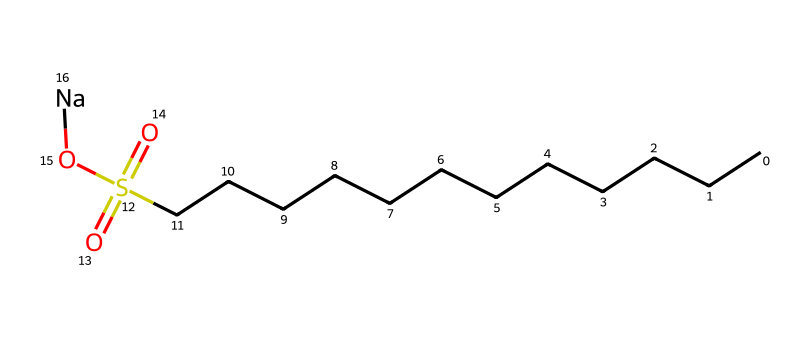What type of chemical is represented by this SMILES? The SMILES represents an alkylbenzene sulfonate, which is known for its use in detergents. The presence of the sulfonate group (S(=O)(=O)O) indicates it's a sulfonic acid derivative, often used for its surfactant properties.
Answer: alkylbenzene sulfonate How many carbon atoms are in this molecule? By analyzing the chain of "C" symbols in the SMILES representation, we count a total of 12 carbon atoms represented here (CCCCCCCCCCCC).
Answer: 12 What does the "Na" represent at the end of the SMILES? The "Na" at the end indicates that this compound is sodium salt of alkylbenzene sulfonate, which enhances its solubility in water, making it effective in cleaning applications.
Answer: sodium How many sulfur atoms are in the molecule? The letter "S" in the SMILES indicates there is one sulfur atom present in the structure, which is part of the sulfonate group.
Answer: 1 What functional group is indicated by "S(=O)(=O)O"? The "S(=O)(=O)O" part of the SMILES shows a sulfonate functional group, which is characterized by a sulfur atom bonded to two oxygen atoms with double bonds and one hydroxyl group. This specific structure is key to its surfactant properties.
Answer: sulfonate Why is this chemical effective in cleaning muddy baseball uniforms? The alkylbenzene sulfonate structure provides hydrophobic carbon chains that disrupt grease and dirt, while the sulfonate group allows it to interact with water, facilitating the removal of dirt and stains from fabrics.
Answer: surfactant properties 